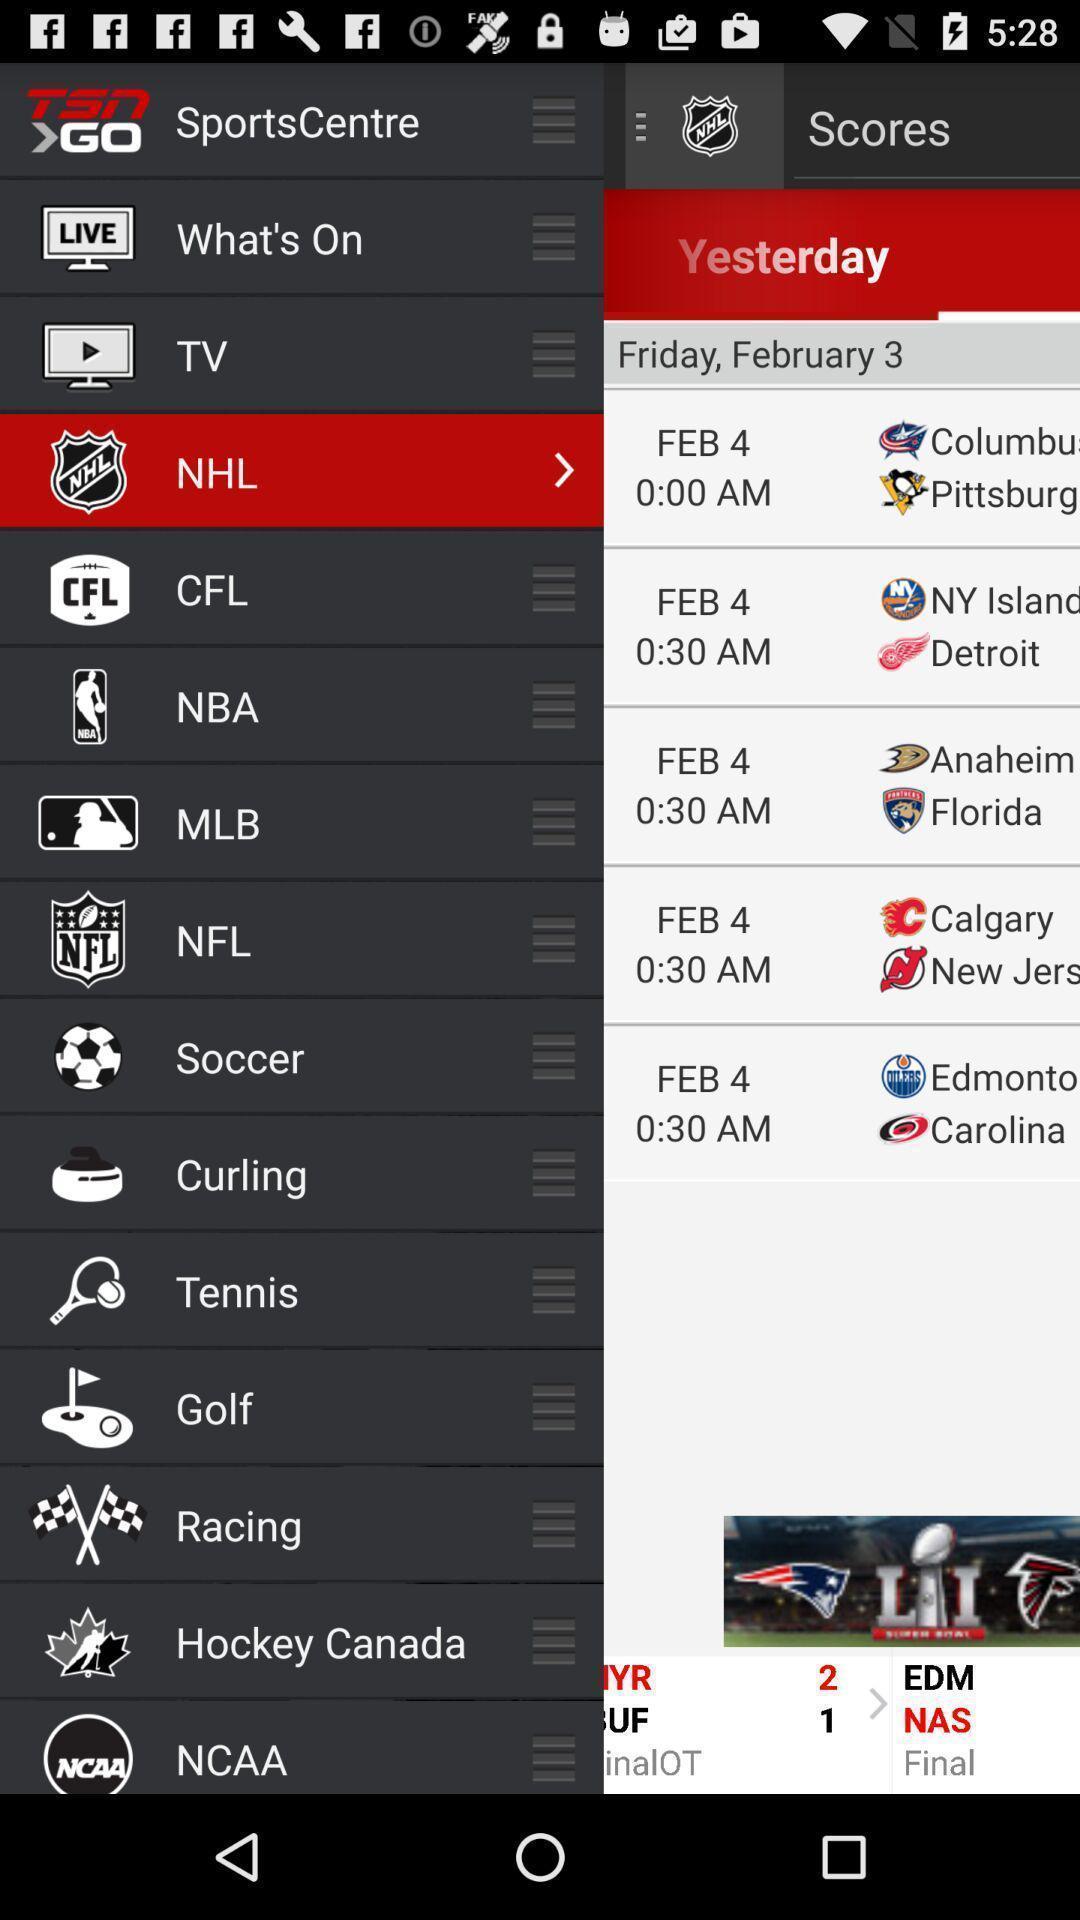Give me a summary of this screen capture. Page displaying with different sports and options. 